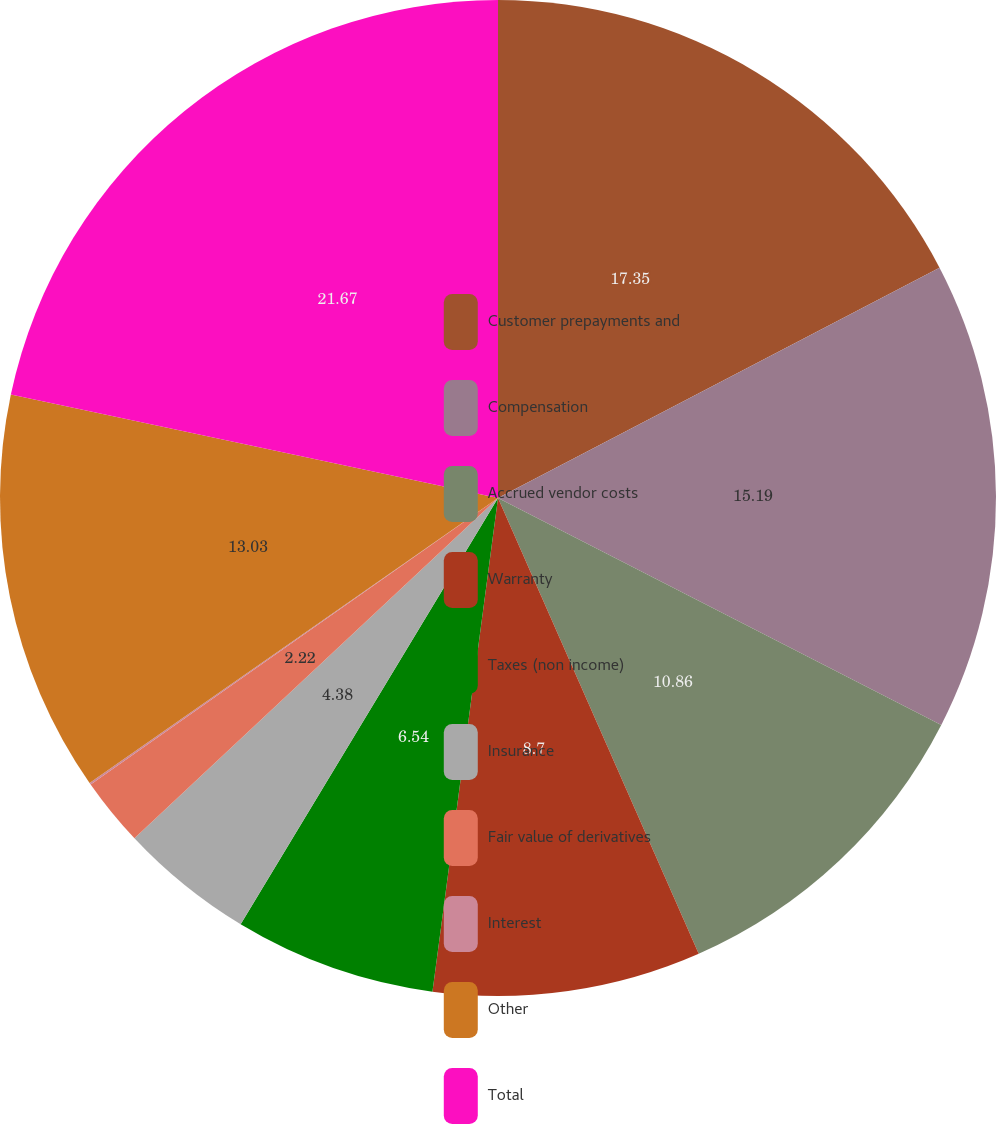Convert chart to OTSL. <chart><loc_0><loc_0><loc_500><loc_500><pie_chart><fcel>Customer prepayments and<fcel>Compensation<fcel>Accrued vendor costs<fcel>Warranty<fcel>Taxes (non income)<fcel>Insurance<fcel>Fair value of derivatives<fcel>Interest<fcel>Other<fcel>Total<nl><fcel>17.34%<fcel>15.18%<fcel>10.86%<fcel>8.7%<fcel>6.54%<fcel>4.38%<fcel>2.22%<fcel>0.06%<fcel>13.02%<fcel>21.66%<nl></chart> 